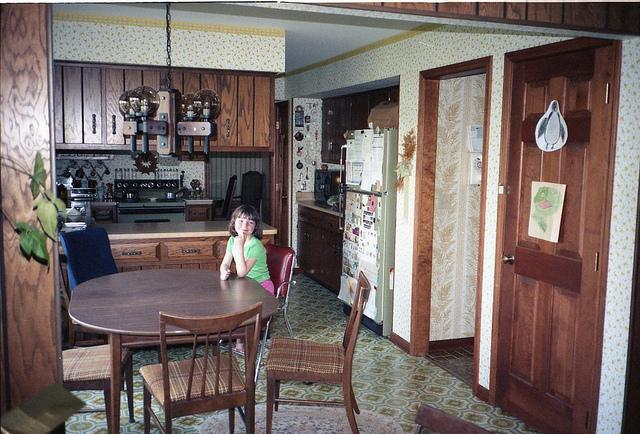In what is the most likely type of structure is this room?

Choices:
A) bridge
B) house
C) store
D) skyscraper house 